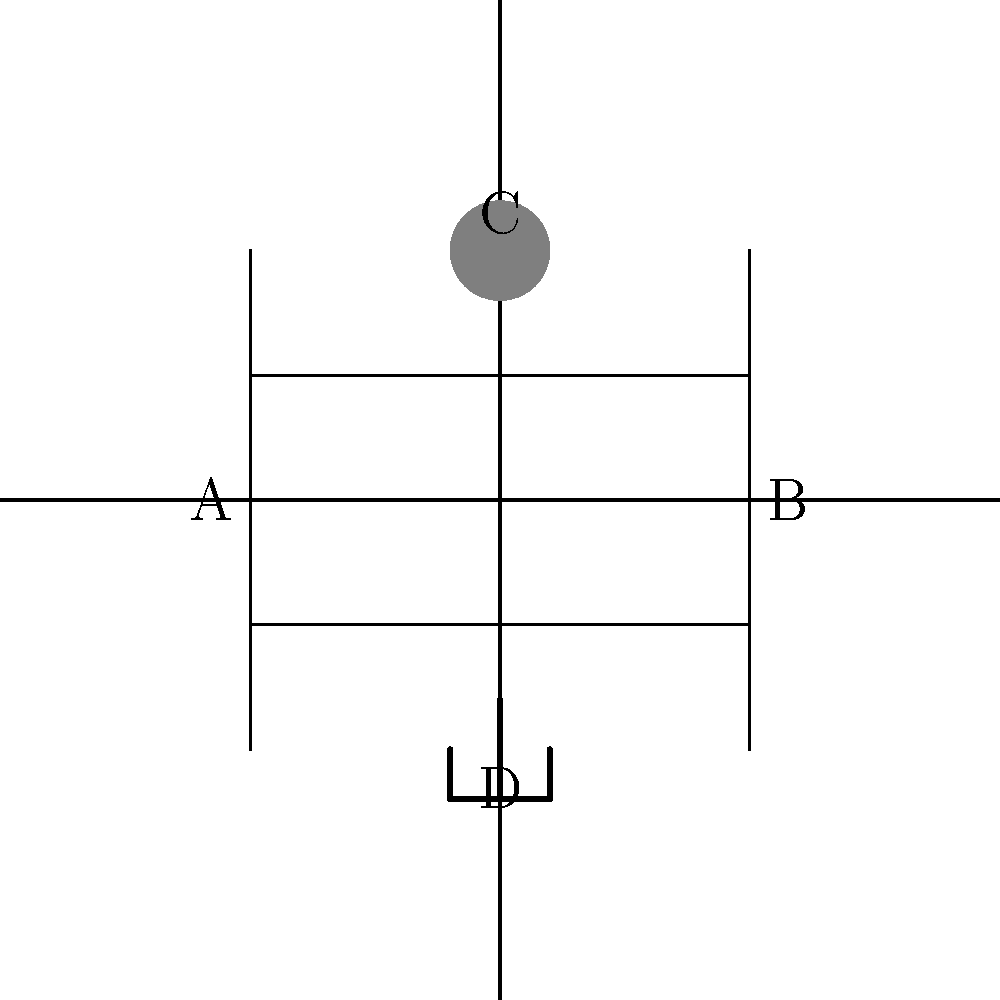In the schematic of a weather station used for crop management, identify the component labeled 'C'. How does this component contribute to monitoring conditions that affect disease-resistant crops? To identify the component and understand its role in monitoring conditions for disease-resistant crops, let's analyze the schematic step-by-step:

1. The schematic shows four main components labeled A, B, C, and D.

2. Component C is represented by a filled circle symbol at the top of the diagram.

3. In electrical engineering, this symbol typically represents a sensor or transducer.

4. In the context of a weather station for crop management, component C is likely an anemometer, which is used to measure wind speed and direction.

5. Wind speed and direction are crucial factors in crop management, especially for disease-resistant crops, because:
   a) Wind can spread plant pathogens and spores, potentially causing disease outbreaks.
   b) Strong winds can damage crops directly, making them more susceptible to diseases.
   c) Wind patterns affect temperature and humidity levels around crops, which can influence disease development.

6. By monitoring wind conditions with an anemometer, farmers can:
   a) Predict potential disease spread and take preventive measures.
   b) Optimize timing for pesticide or fungicide applications.
   c) Adjust irrigation schedules to compensate for increased evaporation due to wind.

7. This information helps farmers make informed decisions to protect their disease-resistant crops and maintain a successful harvest.
Answer: Anemometer; measures wind speed/direction to predict disease spread and optimize crop management. 